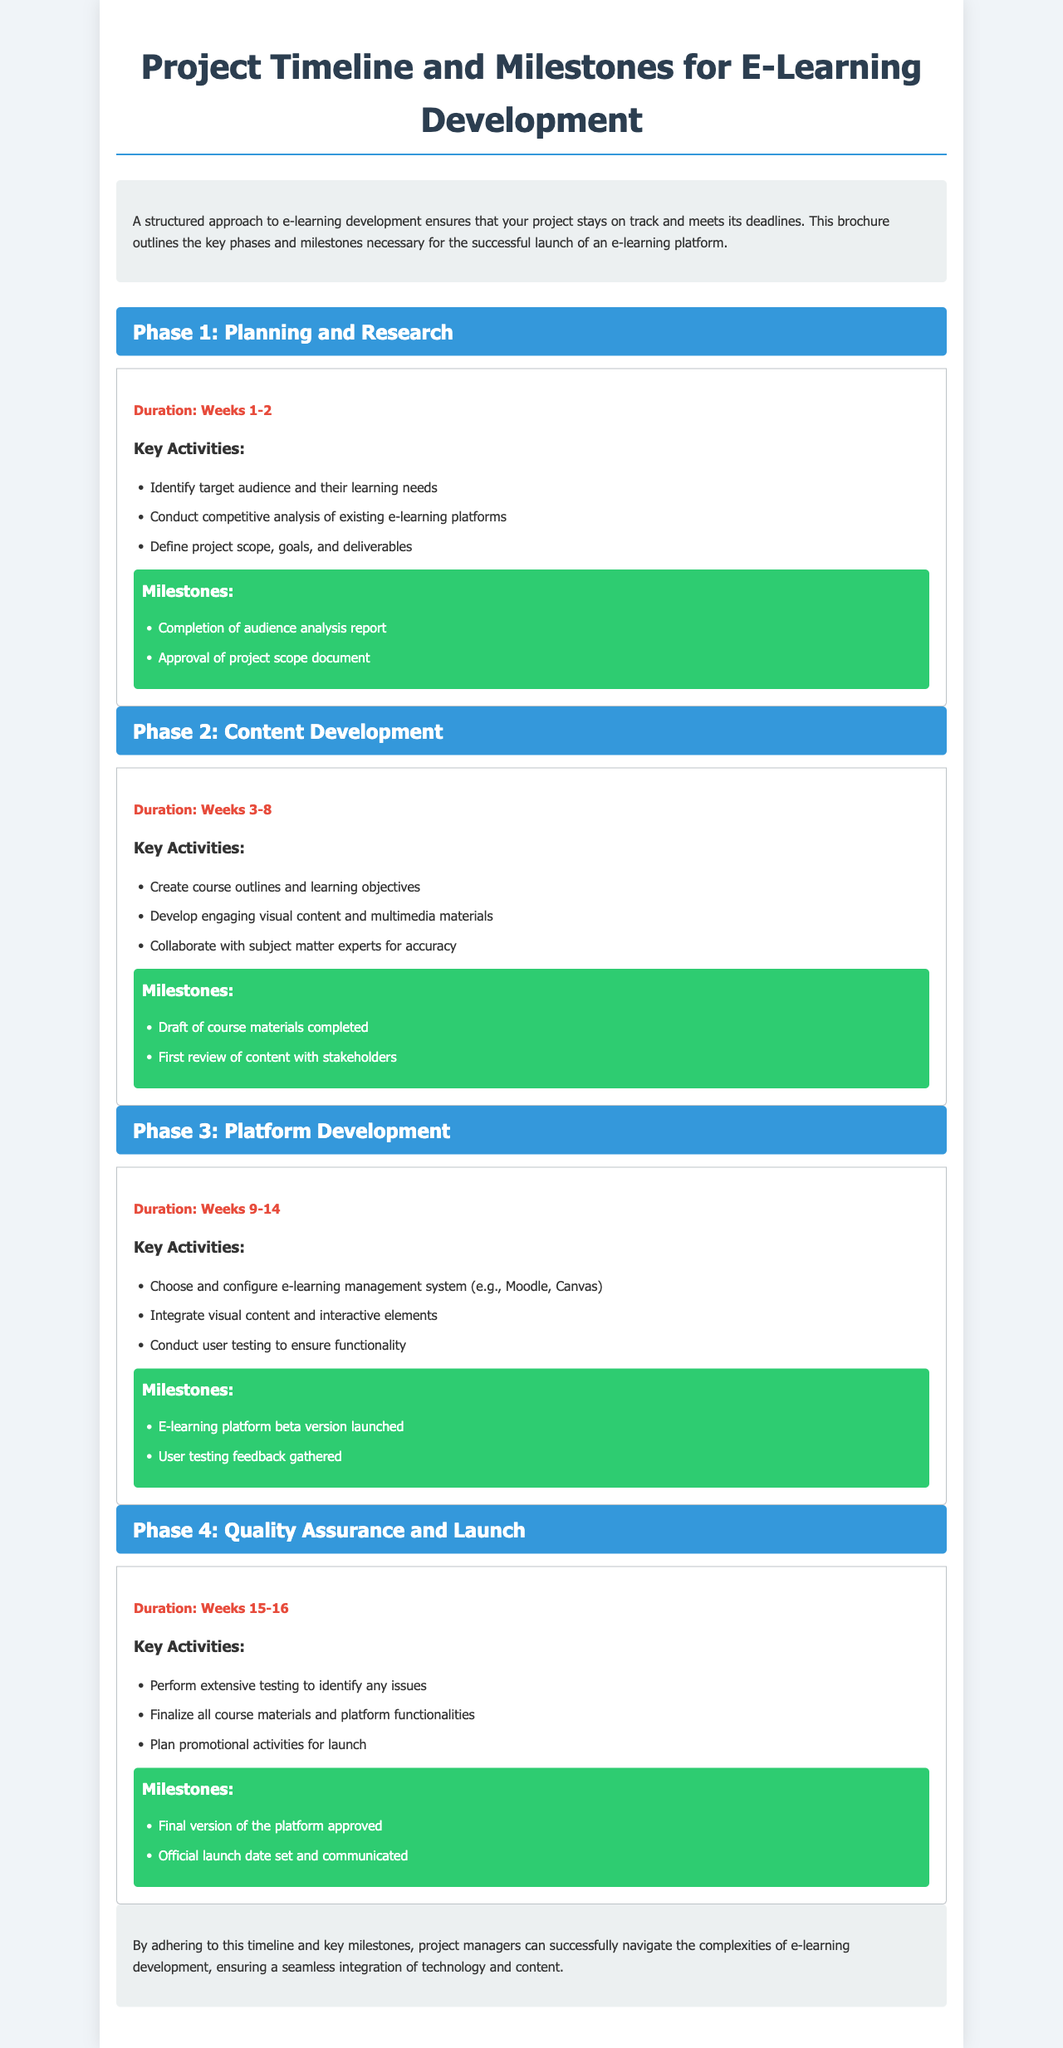What is the duration of Phase 1? The duration is listed clearly in the document under each phase description. For Phase 1, it states "Duration: Weeks 1-2."
Answer: Weeks 1-2 What are the key activities of Phase 2? The document lists the key activities for each phase under their respective headings. For Phase 2, the activities include creating course outlines and developing multimedia materials.
Answer: Create course outlines and learning objectives, Develop engaging visual content and multimedia materials What is the first milestone in Phase 3? Milestones for each phase are outlined in a specific section within each phase. The first milestone for Phase 3 is "E-learning platform beta version launched."
Answer: E-learning platform beta version launched How long does Phase 4 last? The document states the duration for each phase, specifically for Phase 4 as "Duration: Weeks 15-16."
Answer: Weeks 15-16 What color is used for the phase boxes? The document describes the styling used in the brochure; for phases, the color is specifically stated in the CSS class. Phase boxes use the color blue.
Answer: Blue What is the conclusion of the brochure about? The conclusion summarizes the aim of adhering to the timeline and stages for successful project management, focusing on seamless integrations.
Answer: Ensuring a seamless integration of technology and content How many phases are outlined in the document? The content describes four distinct phases, each with dedicated sections detailing activities and milestones.
Answer: Four What is the primary purpose of this brochure? The introduction clarifies the brochure's goal in terms of project planning and execution in e-learning development.
Answer: To outline key phases and milestones necessary for successful launch What type of document is this? The structure and content presentations categorize this as a project timeline brochure specifically for e-learning development.
Answer: Brochure 